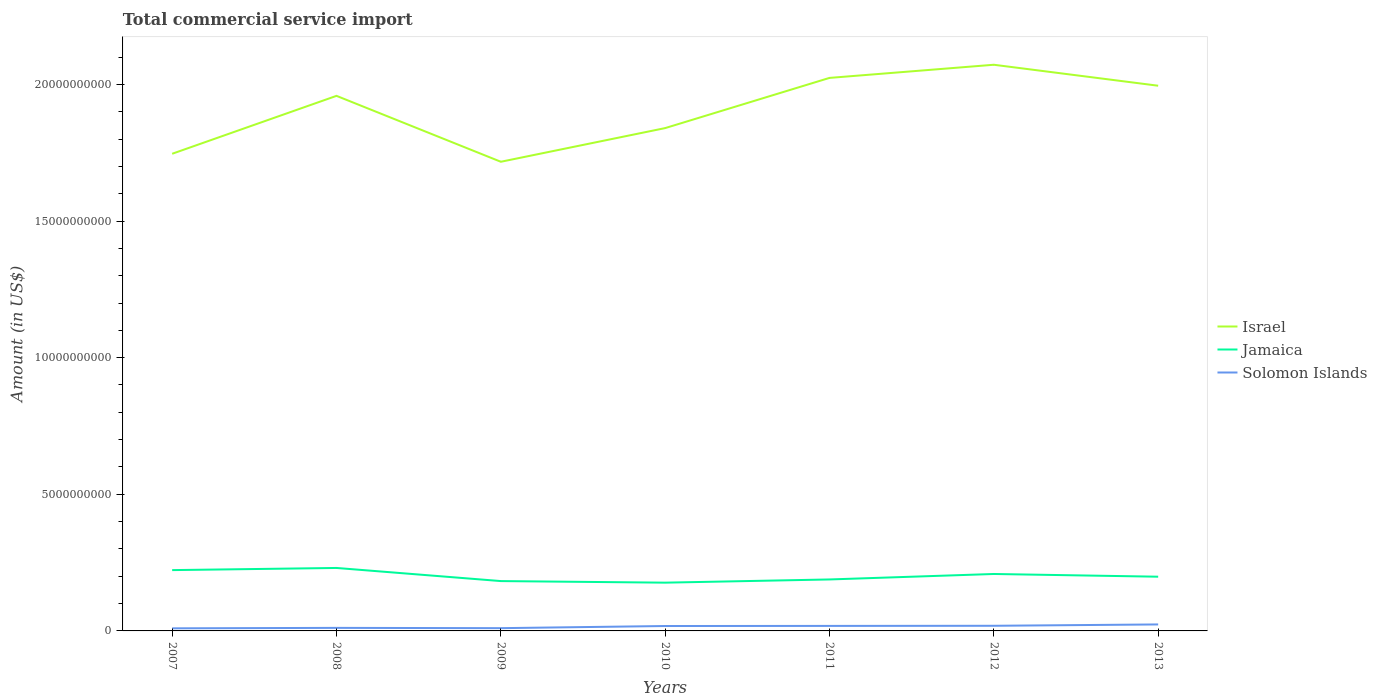Is the number of lines equal to the number of legend labels?
Offer a terse response. Yes. Across all years, what is the maximum total commercial service import in Jamaica?
Your response must be concise. 1.77e+09. In which year was the total commercial service import in Jamaica maximum?
Give a very brief answer. 2010. What is the total total commercial service import in Solomon Islands in the graph?
Provide a short and direct response. -7.22e+07. What is the difference between the highest and the second highest total commercial service import in Solomon Islands?
Ensure brevity in your answer.  1.42e+08. What is the difference between the highest and the lowest total commercial service import in Solomon Islands?
Give a very brief answer. 4. How many lines are there?
Keep it short and to the point. 3. How many years are there in the graph?
Give a very brief answer. 7. Are the values on the major ticks of Y-axis written in scientific E-notation?
Your answer should be compact. No. Does the graph contain any zero values?
Keep it short and to the point. No. What is the title of the graph?
Your answer should be compact. Total commercial service import. Does "Uganda" appear as one of the legend labels in the graph?
Offer a terse response. No. What is the label or title of the X-axis?
Offer a very short reply. Years. What is the Amount (in US$) in Israel in 2007?
Provide a short and direct response. 1.75e+1. What is the Amount (in US$) in Jamaica in 2007?
Give a very brief answer. 2.23e+09. What is the Amount (in US$) of Solomon Islands in 2007?
Keep it short and to the point. 9.48e+07. What is the Amount (in US$) in Israel in 2008?
Your answer should be compact. 1.96e+1. What is the Amount (in US$) in Jamaica in 2008?
Make the answer very short. 2.30e+09. What is the Amount (in US$) in Solomon Islands in 2008?
Your answer should be compact. 1.11e+08. What is the Amount (in US$) in Israel in 2009?
Your response must be concise. 1.72e+1. What is the Amount (in US$) of Jamaica in 2009?
Give a very brief answer. 1.82e+09. What is the Amount (in US$) of Solomon Islands in 2009?
Provide a short and direct response. 1.01e+08. What is the Amount (in US$) in Israel in 2010?
Ensure brevity in your answer.  1.84e+1. What is the Amount (in US$) in Jamaica in 2010?
Offer a very short reply. 1.77e+09. What is the Amount (in US$) in Solomon Islands in 2010?
Give a very brief answer. 1.80e+08. What is the Amount (in US$) of Israel in 2011?
Ensure brevity in your answer.  2.02e+1. What is the Amount (in US$) of Jamaica in 2011?
Your answer should be very brief. 1.88e+09. What is the Amount (in US$) of Solomon Islands in 2011?
Keep it short and to the point. 1.83e+08. What is the Amount (in US$) in Israel in 2012?
Ensure brevity in your answer.  2.07e+1. What is the Amount (in US$) of Jamaica in 2012?
Keep it short and to the point. 2.08e+09. What is the Amount (in US$) of Solomon Islands in 2012?
Offer a terse response. 1.88e+08. What is the Amount (in US$) in Israel in 2013?
Your answer should be very brief. 2.00e+1. What is the Amount (in US$) of Jamaica in 2013?
Give a very brief answer. 1.98e+09. What is the Amount (in US$) of Solomon Islands in 2013?
Your answer should be compact. 2.37e+08. Across all years, what is the maximum Amount (in US$) in Israel?
Your answer should be very brief. 2.07e+1. Across all years, what is the maximum Amount (in US$) in Jamaica?
Offer a very short reply. 2.30e+09. Across all years, what is the maximum Amount (in US$) of Solomon Islands?
Provide a short and direct response. 2.37e+08. Across all years, what is the minimum Amount (in US$) of Israel?
Your response must be concise. 1.72e+1. Across all years, what is the minimum Amount (in US$) in Jamaica?
Your answer should be very brief. 1.77e+09. Across all years, what is the minimum Amount (in US$) in Solomon Islands?
Make the answer very short. 9.48e+07. What is the total Amount (in US$) in Israel in the graph?
Your response must be concise. 1.34e+11. What is the total Amount (in US$) in Jamaica in the graph?
Your answer should be very brief. 1.41e+1. What is the total Amount (in US$) of Solomon Islands in the graph?
Keep it short and to the point. 1.10e+09. What is the difference between the Amount (in US$) in Israel in 2007 and that in 2008?
Your response must be concise. -2.12e+09. What is the difference between the Amount (in US$) in Jamaica in 2007 and that in 2008?
Give a very brief answer. -7.87e+07. What is the difference between the Amount (in US$) in Solomon Islands in 2007 and that in 2008?
Offer a very short reply. -1.65e+07. What is the difference between the Amount (in US$) in Israel in 2007 and that in 2009?
Ensure brevity in your answer.  2.92e+08. What is the difference between the Amount (in US$) of Jamaica in 2007 and that in 2009?
Provide a succinct answer. 4.02e+08. What is the difference between the Amount (in US$) in Solomon Islands in 2007 and that in 2009?
Make the answer very short. -6.20e+06. What is the difference between the Amount (in US$) in Israel in 2007 and that in 2010?
Give a very brief answer. -9.40e+08. What is the difference between the Amount (in US$) of Jamaica in 2007 and that in 2010?
Provide a short and direct response. 4.59e+08. What is the difference between the Amount (in US$) in Solomon Islands in 2007 and that in 2010?
Ensure brevity in your answer.  -8.48e+07. What is the difference between the Amount (in US$) in Israel in 2007 and that in 2011?
Offer a terse response. -2.78e+09. What is the difference between the Amount (in US$) of Jamaica in 2007 and that in 2011?
Keep it short and to the point. 3.42e+08. What is the difference between the Amount (in US$) of Solomon Islands in 2007 and that in 2011?
Your answer should be compact. -8.87e+07. What is the difference between the Amount (in US$) of Israel in 2007 and that in 2012?
Give a very brief answer. -3.26e+09. What is the difference between the Amount (in US$) of Jamaica in 2007 and that in 2012?
Keep it short and to the point. 1.42e+08. What is the difference between the Amount (in US$) of Solomon Islands in 2007 and that in 2012?
Provide a short and direct response. -9.35e+07. What is the difference between the Amount (in US$) of Israel in 2007 and that in 2013?
Keep it short and to the point. -2.49e+09. What is the difference between the Amount (in US$) of Jamaica in 2007 and that in 2013?
Provide a succinct answer. 2.41e+08. What is the difference between the Amount (in US$) in Solomon Islands in 2007 and that in 2013?
Make the answer very short. -1.42e+08. What is the difference between the Amount (in US$) of Israel in 2008 and that in 2009?
Offer a very short reply. 2.41e+09. What is the difference between the Amount (in US$) in Jamaica in 2008 and that in 2009?
Ensure brevity in your answer.  4.80e+08. What is the difference between the Amount (in US$) of Solomon Islands in 2008 and that in 2009?
Your answer should be compact. 1.03e+07. What is the difference between the Amount (in US$) in Israel in 2008 and that in 2010?
Offer a very short reply. 1.18e+09. What is the difference between the Amount (in US$) in Jamaica in 2008 and that in 2010?
Offer a very short reply. 5.38e+08. What is the difference between the Amount (in US$) of Solomon Islands in 2008 and that in 2010?
Give a very brief answer. -6.83e+07. What is the difference between the Amount (in US$) in Israel in 2008 and that in 2011?
Your answer should be very brief. -6.57e+08. What is the difference between the Amount (in US$) in Jamaica in 2008 and that in 2011?
Provide a short and direct response. 4.21e+08. What is the difference between the Amount (in US$) of Solomon Islands in 2008 and that in 2011?
Your response must be concise. -7.22e+07. What is the difference between the Amount (in US$) of Israel in 2008 and that in 2012?
Ensure brevity in your answer.  -1.14e+09. What is the difference between the Amount (in US$) of Jamaica in 2008 and that in 2012?
Provide a succinct answer. 2.20e+08. What is the difference between the Amount (in US$) of Solomon Islands in 2008 and that in 2012?
Ensure brevity in your answer.  -7.70e+07. What is the difference between the Amount (in US$) of Israel in 2008 and that in 2013?
Provide a succinct answer. -3.71e+08. What is the difference between the Amount (in US$) of Jamaica in 2008 and that in 2013?
Your answer should be compact. 3.20e+08. What is the difference between the Amount (in US$) in Solomon Islands in 2008 and that in 2013?
Offer a terse response. -1.26e+08. What is the difference between the Amount (in US$) in Israel in 2009 and that in 2010?
Keep it short and to the point. -1.23e+09. What is the difference between the Amount (in US$) in Jamaica in 2009 and that in 2010?
Your answer should be very brief. 5.75e+07. What is the difference between the Amount (in US$) in Solomon Islands in 2009 and that in 2010?
Make the answer very short. -7.86e+07. What is the difference between the Amount (in US$) of Israel in 2009 and that in 2011?
Provide a succinct answer. -3.07e+09. What is the difference between the Amount (in US$) in Jamaica in 2009 and that in 2011?
Provide a succinct answer. -5.96e+07. What is the difference between the Amount (in US$) in Solomon Islands in 2009 and that in 2011?
Offer a very short reply. -8.25e+07. What is the difference between the Amount (in US$) of Israel in 2009 and that in 2012?
Make the answer very short. -3.55e+09. What is the difference between the Amount (in US$) of Jamaica in 2009 and that in 2012?
Keep it short and to the point. -2.60e+08. What is the difference between the Amount (in US$) of Solomon Islands in 2009 and that in 2012?
Your answer should be compact. -8.73e+07. What is the difference between the Amount (in US$) of Israel in 2009 and that in 2013?
Keep it short and to the point. -2.78e+09. What is the difference between the Amount (in US$) of Jamaica in 2009 and that in 2013?
Keep it short and to the point. -1.60e+08. What is the difference between the Amount (in US$) of Solomon Islands in 2009 and that in 2013?
Your answer should be compact. -1.36e+08. What is the difference between the Amount (in US$) of Israel in 2010 and that in 2011?
Offer a very short reply. -1.84e+09. What is the difference between the Amount (in US$) in Jamaica in 2010 and that in 2011?
Give a very brief answer. -1.17e+08. What is the difference between the Amount (in US$) of Solomon Islands in 2010 and that in 2011?
Your answer should be very brief. -3.90e+06. What is the difference between the Amount (in US$) of Israel in 2010 and that in 2012?
Your answer should be compact. -2.32e+09. What is the difference between the Amount (in US$) in Jamaica in 2010 and that in 2012?
Offer a very short reply. -3.17e+08. What is the difference between the Amount (in US$) in Solomon Islands in 2010 and that in 2012?
Keep it short and to the point. -8.73e+06. What is the difference between the Amount (in US$) in Israel in 2010 and that in 2013?
Provide a succinct answer. -1.55e+09. What is the difference between the Amount (in US$) in Jamaica in 2010 and that in 2013?
Make the answer very short. -2.18e+08. What is the difference between the Amount (in US$) of Solomon Islands in 2010 and that in 2013?
Offer a terse response. -5.77e+07. What is the difference between the Amount (in US$) in Israel in 2011 and that in 2012?
Provide a succinct answer. -4.81e+08. What is the difference between the Amount (in US$) in Jamaica in 2011 and that in 2012?
Your response must be concise. -2.00e+08. What is the difference between the Amount (in US$) in Solomon Islands in 2011 and that in 2012?
Your response must be concise. -4.83e+06. What is the difference between the Amount (in US$) of Israel in 2011 and that in 2013?
Ensure brevity in your answer.  2.86e+08. What is the difference between the Amount (in US$) in Jamaica in 2011 and that in 2013?
Offer a terse response. -1.01e+08. What is the difference between the Amount (in US$) in Solomon Islands in 2011 and that in 2013?
Keep it short and to the point. -5.38e+07. What is the difference between the Amount (in US$) of Israel in 2012 and that in 2013?
Offer a very short reply. 7.67e+08. What is the difference between the Amount (in US$) of Jamaica in 2012 and that in 2013?
Provide a short and direct response. 9.95e+07. What is the difference between the Amount (in US$) of Solomon Islands in 2012 and that in 2013?
Your response must be concise. -4.90e+07. What is the difference between the Amount (in US$) in Israel in 2007 and the Amount (in US$) in Jamaica in 2008?
Your answer should be very brief. 1.52e+1. What is the difference between the Amount (in US$) of Israel in 2007 and the Amount (in US$) of Solomon Islands in 2008?
Make the answer very short. 1.74e+1. What is the difference between the Amount (in US$) in Jamaica in 2007 and the Amount (in US$) in Solomon Islands in 2008?
Make the answer very short. 2.11e+09. What is the difference between the Amount (in US$) of Israel in 2007 and the Amount (in US$) of Jamaica in 2009?
Give a very brief answer. 1.56e+1. What is the difference between the Amount (in US$) in Israel in 2007 and the Amount (in US$) in Solomon Islands in 2009?
Ensure brevity in your answer.  1.74e+1. What is the difference between the Amount (in US$) of Jamaica in 2007 and the Amount (in US$) of Solomon Islands in 2009?
Provide a succinct answer. 2.12e+09. What is the difference between the Amount (in US$) in Israel in 2007 and the Amount (in US$) in Jamaica in 2010?
Provide a short and direct response. 1.57e+1. What is the difference between the Amount (in US$) of Israel in 2007 and the Amount (in US$) of Solomon Islands in 2010?
Keep it short and to the point. 1.73e+1. What is the difference between the Amount (in US$) in Jamaica in 2007 and the Amount (in US$) in Solomon Islands in 2010?
Provide a succinct answer. 2.05e+09. What is the difference between the Amount (in US$) of Israel in 2007 and the Amount (in US$) of Jamaica in 2011?
Offer a terse response. 1.56e+1. What is the difference between the Amount (in US$) in Israel in 2007 and the Amount (in US$) in Solomon Islands in 2011?
Make the answer very short. 1.73e+1. What is the difference between the Amount (in US$) of Jamaica in 2007 and the Amount (in US$) of Solomon Islands in 2011?
Offer a very short reply. 2.04e+09. What is the difference between the Amount (in US$) of Israel in 2007 and the Amount (in US$) of Jamaica in 2012?
Provide a short and direct response. 1.54e+1. What is the difference between the Amount (in US$) of Israel in 2007 and the Amount (in US$) of Solomon Islands in 2012?
Ensure brevity in your answer.  1.73e+1. What is the difference between the Amount (in US$) of Jamaica in 2007 and the Amount (in US$) of Solomon Islands in 2012?
Give a very brief answer. 2.04e+09. What is the difference between the Amount (in US$) in Israel in 2007 and the Amount (in US$) in Jamaica in 2013?
Make the answer very short. 1.55e+1. What is the difference between the Amount (in US$) in Israel in 2007 and the Amount (in US$) in Solomon Islands in 2013?
Ensure brevity in your answer.  1.72e+1. What is the difference between the Amount (in US$) of Jamaica in 2007 and the Amount (in US$) of Solomon Islands in 2013?
Offer a terse response. 1.99e+09. What is the difference between the Amount (in US$) of Israel in 2008 and the Amount (in US$) of Jamaica in 2009?
Keep it short and to the point. 1.78e+1. What is the difference between the Amount (in US$) of Israel in 2008 and the Amount (in US$) of Solomon Islands in 2009?
Your answer should be very brief. 1.95e+1. What is the difference between the Amount (in US$) of Jamaica in 2008 and the Amount (in US$) of Solomon Islands in 2009?
Your answer should be very brief. 2.20e+09. What is the difference between the Amount (in US$) in Israel in 2008 and the Amount (in US$) in Jamaica in 2010?
Your answer should be very brief. 1.78e+1. What is the difference between the Amount (in US$) of Israel in 2008 and the Amount (in US$) of Solomon Islands in 2010?
Your response must be concise. 1.94e+1. What is the difference between the Amount (in US$) of Jamaica in 2008 and the Amount (in US$) of Solomon Islands in 2010?
Provide a succinct answer. 2.12e+09. What is the difference between the Amount (in US$) of Israel in 2008 and the Amount (in US$) of Jamaica in 2011?
Keep it short and to the point. 1.77e+1. What is the difference between the Amount (in US$) in Israel in 2008 and the Amount (in US$) in Solomon Islands in 2011?
Give a very brief answer. 1.94e+1. What is the difference between the Amount (in US$) in Jamaica in 2008 and the Amount (in US$) in Solomon Islands in 2011?
Keep it short and to the point. 2.12e+09. What is the difference between the Amount (in US$) of Israel in 2008 and the Amount (in US$) of Jamaica in 2012?
Offer a very short reply. 1.75e+1. What is the difference between the Amount (in US$) of Israel in 2008 and the Amount (in US$) of Solomon Islands in 2012?
Make the answer very short. 1.94e+1. What is the difference between the Amount (in US$) in Jamaica in 2008 and the Amount (in US$) in Solomon Islands in 2012?
Offer a very short reply. 2.12e+09. What is the difference between the Amount (in US$) in Israel in 2008 and the Amount (in US$) in Jamaica in 2013?
Your answer should be compact. 1.76e+1. What is the difference between the Amount (in US$) in Israel in 2008 and the Amount (in US$) in Solomon Islands in 2013?
Provide a succinct answer. 1.93e+1. What is the difference between the Amount (in US$) of Jamaica in 2008 and the Amount (in US$) of Solomon Islands in 2013?
Provide a short and direct response. 2.07e+09. What is the difference between the Amount (in US$) in Israel in 2009 and the Amount (in US$) in Jamaica in 2010?
Offer a very short reply. 1.54e+1. What is the difference between the Amount (in US$) of Israel in 2009 and the Amount (in US$) of Solomon Islands in 2010?
Offer a very short reply. 1.70e+1. What is the difference between the Amount (in US$) of Jamaica in 2009 and the Amount (in US$) of Solomon Islands in 2010?
Offer a terse response. 1.64e+09. What is the difference between the Amount (in US$) of Israel in 2009 and the Amount (in US$) of Jamaica in 2011?
Provide a short and direct response. 1.53e+1. What is the difference between the Amount (in US$) of Israel in 2009 and the Amount (in US$) of Solomon Islands in 2011?
Make the answer very short. 1.70e+1. What is the difference between the Amount (in US$) in Jamaica in 2009 and the Amount (in US$) in Solomon Islands in 2011?
Offer a terse response. 1.64e+09. What is the difference between the Amount (in US$) in Israel in 2009 and the Amount (in US$) in Jamaica in 2012?
Give a very brief answer. 1.51e+1. What is the difference between the Amount (in US$) in Israel in 2009 and the Amount (in US$) in Solomon Islands in 2012?
Keep it short and to the point. 1.70e+1. What is the difference between the Amount (in US$) in Jamaica in 2009 and the Amount (in US$) in Solomon Islands in 2012?
Provide a short and direct response. 1.64e+09. What is the difference between the Amount (in US$) in Israel in 2009 and the Amount (in US$) in Jamaica in 2013?
Your answer should be compact. 1.52e+1. What is the difference between the Amount (in US$) in Israel in 2009 and the Amount (in US$) in Solomon Islands in 2013?
Make the answer very short. 1.69e+1. What is the difference between the Amount (in US$) in Jamaica in 2009 and the Amount (in US$) in Solomon Islands in 2013?
Your answer should be very brief. 1.59e+09. What is the difference between the Amount (in US$) in Israel in 2010 and the Amount (in US$) in Jamaica in 2011?
Give a very brief answer. 1.65e+1. What is the difference between the Amount (in US$) of Israel in 2010 and the Amount (in US$) of Solomon Islands in 2011?
Your answer should be very brief. 1.82e+1. What is the difference between the Amount (in US$) in Jamaica in 2010 and the Amount (in US$) in Solomon Islands in 2011?
Provide a succinct answer. 1.58e+09. What is the difference between the Amount (in US$) in Israel in 2010 and the Amount (in US$) in Jamaica in 2012?
Make the answer very short. 1.63e+1. What is the difference between the Amount (in US$) of Israel in 2010 and the Amount (in US$) of Solomon Islands in 2012?
Provide a short and direct response. 1.82e+1. What is the difference between the Amount (in US$) in Jamaica in 2010 and the Amount (in US$) in Solomon Islands in 2012?
Your answer should be compact. 1.58e+09. What is the difference between the Amount (in US$) of Israel in 2010 and the Amount (in US$) of Jamaica in 2013?
Your answer should be compact. 1.64e+1. What is the difference between the Amount (in US$) of Israel in 2010 and the Amount (in US$) of Solomon Islands in 2013?
Provide a succinct answer. 1.82e+1. What is the difference between the Amount (in US$) of Jamaica in 2010 and the Amount (in US$) of Solomon Islands in 2013?
Make the answer very short. 1.53e+09. What is the difference between the Amount (in US$) in Israel in 2011 and the Amount (in US$) in Jamaica in 2012?
Offer a very short reply. 1.82e+1. What is the difference between the Amount (in US$) in Israel in 2011 and the Amount (in US$) in Solomon Islands in 2012?
Provide a succinct answer. 2.01e+1. What is the difference between the Amount (in US$) of Jamaica in 2011 and the Amount (in US$) of Solomon Islands in 2012?
Provide a short and direct response. 1.70e+09. What is the difference between the Amount (in US$) in Israel in 2011 and the Amount (in US$) in Jamaica in 2013?
Your response must be concise. 1.83e+1. What is the difference between the Amount (in US$) in Israel in 2011 and the Amount (in US$) in Solomon Islands in 2013?
Make the answer very short. 2.00e+1. What is the difference between the Amount (in US$) of Jamaica in 2011 and the Amount (in US$) of Solomon Islands in 2013?
Make the answer very short. 1.65e+09. What is the difference between the Amount (in US$) of Israel in 2012 and the Amount (in US$) of Jamaica in 2013?
Provide a succinct answer. 1.87e+1. What is the difference between the Amount (in US$) in Israel in 2012 and the Amount (in US$) in Solomon Islands in 2013?
Your answer should be very brief. 2.05e+1. What is the difference between the Amount (in US$) of Jamaica in 2012 and the Amount (in US$) of Solomon Islands in 2013?
Your answer should be compact. 1.85e+09. What is the average Amount (in US$) in Israel per year?
Provide a succinct answer. 1.91e+1. What is the average Amount (in US$) in Jamaica per year?
Give a very brief answer. 2.01e+09. What is the average Amount (in US$) in Solomon Islands per year?
Offer a terse response. 1.56e+08. In the year 2007, what is the difference between the Amount (in US$) of Israel and Amount (in US$) of Jamaica?
Ensure brevity in your answer.  1.52e+1. In the year 2007, what is the difference between the Amount (in US$) of Israel and Amount (in US$) of Solomon Islands?
Give a very brief answer. 1.74e+1. In the year 2007, what is the difference between the Amount (in US$) of Jamaica and Amount (in US$) of Solomon Islands?
Ensure brevity in your answer.  2.13e+09. In the year 2008, what is the difference between the Amount (in US$) of Israel and Amount (in US$) of Jamaica?
Keep it short and to the point. 1.73e+1. In the year 2008, what is the difference between the Amount (in US$) in Israel and Amount (in US$) in Solomon Islands?
Provide a short and direct response. 1.95e+1. In the year 2008, what is the difference between the Amount (in US$) of Jamaica and Amount (in US$) of Solomon Islands?
Your answer should be compact. 2.19e+09. In the year 2009, what is the difference between the Amount (in US$) in Israel and Amount (in US$) in Jamaica?
Offer a very short reply. 1.53e+1. In the year 2009, what is the difference between the Amount (in US$) of Israel and Amount (in US$) of Solomon Islands?
Offer a very short reply. 1.71e+1. In the year 2009, what is the difference between the Amount (in US$) of Jamaica and Amount (in US$) of Solomon Islands?
Your answer should be very brief. 1.72e+09. In the year 2010, what is the difference between the Amount (in US$) in Israel and Amount (in US$) in Jamaica?
Your response must be concise. 1.66e+1. In the year 2010, what is the difference between the Amount (in US$) of Israel and Amount (in US$) of Solomon Islands?
Offer a terse response. 1.82e+1. In the year 2010, what is the difference between the Amount (in US$) in Jamaica and Amount (in US$) in Solomon Islands?
Your answer should be very brief. 1.59e+09. In the year 2011, what is the difference between the Amount (in US$) of Israel and Amount (in US$) of Jamaica?
Make the answer very short. 1.84e+1. In the year 2011, what is the difference between the Amount (in US$) in Israel and Amount (in US$) in Solomon Islands?
Your answer should be very brief. 2.01e+1. In the year 2011, what is the difference between the Amount (in US$) of Jamaica and Amount (in US$) of Solomon Islands?
Make the answer very short. 1.70e+09. In the year 2012, what is the difference between the Amount (in US$) in Israel and Amount (in US$) in Jamaica?
Ensure brevity in your answer.  1.86e+1. In the year 2012, what is the difference between the Amount (in US$) of Israel and Amount (in US$) of Solomon Islands?
Your answer should be very brief. 2.05e+1. In the year 2012, what is the difference between the Amount (in US$) of Jamaica and Amount (in US$) of Solomon Islands?
Ensure brevity in your answer.  1.90e+09. In the year 2013, what is the difference between the Amount (in US$) of Israel and Amount (in US$) of Jamaica?
Offer a very short reply. 1.80e+1. In the year 2013, what is the difference between the Amount (in US$) of Israel and Amount (in US$) of Solomon Islands?
Provide a short and direct response. 1.97e+1. In the year 2013, what is the difference between the Amount (in US$) in Jamaica and Amount (in US$) in Solomon Islands?
Your answer should be compact. 1.75e+09. What is the ratio of the Amount (in US$) in Israel in 2007 to that in 2008?
Provide a short and direct response. 0.89. What is the ratio of the Amount (in US$) of Jamaica in 2007 to that in 2008?
Provide a succinct answer. 0.97. What is the ratio of the Amount (in US$) of Solomon Islands in 2007 to that in 2008?
Ensure brevity in your answer.  0.85. What is the ratio of the Amount (in US$) of Israel in 2007 to that in 2009?
Offer a terse response. 1.02. What is the ratio of the Amount (in US$) in Jamaica in 2007 to that in 2009?
Make the answer very short. 1.22. What is the ratio of the Amount (in US$) in Solomon Islands in 2007 to that in 2009?
Keep it short and to the point. 0.94. What is the ratio of the Amount (in US$) in Israel in 2007 to that in 2010?
Give a very brief answer. 0.95. What is the ratio of the Amount (in US$) in Jamaica in 2007 to that in 2010?
Provide a short and direct response. 1.26. What is the ratio of the Amount (in US$) in Solomon Islands in 2007 to that in 2010?
Offer a very short reply. 0.53. What is the ratio of the Amount (in US$) in Israel in 2007 to that in 2011?
Your answer should be compact. 0.86. What is the ratio of the Amount (in US$) of Jamaica in 2007 to that in 2011?
Offer a very short reply. 1.18. What is the ratio of the Amount (in US$) in Solomon Islands in 2007 to that in 2011?
Give a very brief answer. 0.52. What is the ratio of the Amount (in US$) of Israel in 2007 to that in 2012?
Provide a short and direct response. 0.84. What is the ratio of the Amount (in US$) of Jamaica in 2007 to that in 2012?
Ensure brevity in your answer.  1.07. What is the ratio of the Amount (in US$) of Solomon Islands in 2007 to that in 2012?
Your response must be concise. 0.5. What is the ratio of the Amount (in US$) of Israel in 2007 to that in 2013?
Give a very brief answer. 0.88. What is the ratio of the Amount (in US$) of Jamaica in 2007 to that in 2013?
Ensure brevity in your answer.  1.12. What is the ratio of the Amount (in US$) of Solomon Islands in 2007 to that in 2013?
Give a very brief answer. 0.4. What is the ratio of the Amount (in US$) in Israel in 2008 to that in 2009?
Make the answer very short. 1.14. What is the ratio of the Amount (in US$) in Jamaica in 2008 to that in 2009?
Make the answer very short. 1.26. What is the ratio of the Amount (in US$) of Solomon Islands in 2008 to that in 2009?
Make the answer very short. 1.1. What is the ratio of the Amount (in US$) in Israel in 2008 to that in 2010?
Offer a very short reply. 1.06. What is the ratio of the Amount (in US$) in Jamaica in 2008 to that in 2010?
Your response must be concise. 1.3. What is the ratio of the Amount (in US$) in Solomon Islands in 2008 to that in 2010?
Offer a terse response. 0.62. What is the ratio of the Amount (in US$) in Israel in 2008 to that in 2011?
Offer a very short reply. 0.97. What is the ratio of the Amount (in US$) in Jamaica in 2008 to that in 2011?
Provide a short and direct response. 1.22. What is the ratio of the Amount (in US$) of Solomon Islands in 2008 to that in 2011?
Your response must be concise. 0.61. What is the ratio of the Amount (in US$) in Israel in 2008 to that in 2012?
Offer a terse response. 0.95. What is the ratio of the Amount (in US$) in Jamaica in 2008 to that in 2012?
Offer a terse response. 1.11. What is the ratio of the Amount (in US$) of Solomon Islands in 2008 to that in 2012?
Provide a short and direct response. 0.59. What is the ratio of the Amount (in US$) in Israel in 2008 to that in 2013?
Offer a terse response. 0.98. What is the ratio of the Amount (in US$) of Jamaica in 2008 to that in 2013?
Offer a terse response. 1.16. What is the ratio of the Amount (in US$) of Solomon Islands in 2008 to that in 2013?
Make the answer very short. 0.47. What is the ratio of the Amount (in US$) in Israel in 2009 to that in 2010?
Your response must be concise. 0.93. What is the ratio of the Amount (in US$) in Jamaica in 2009 to that in 2010?
Give a very brief answer. 1.03. What is the ratio of the Amount (in US$) in Solomon Islands in 2009 to that in 2010?
Offer a very short reply. 0.56. What is the ratio of the Amount (in US$) in Israel in 2009 to that in 2011?
Give a very brief answer. 0.85. What is the ratio of the Amount (in US$) of Jamaica in 2009 to that in 2011?
Offer a very short reply. 0.97. What is the ratio of the Amount (in US$) in Solomon Islands in 2009 to that in 2011?
Ensure brevity in your answer.  0.55. What is the ratio of the Amount (in US$) in Israel in 2009 to that in 2012?
Your response must be concise. 0.83. What is the ratio of the Amount (in US$) of Jamaica in 2009 to that in 2012?
Your answer should be very brief. 0.88. What is the ratio of the Amount (in US$) in Solomon Islands in 2009 to that in 2012?
Provide a succinct answer. 0.54. What is the ratio of the Amount (in US$) of Israel in 2009 to that in 2013?
Ensure brevity in your answer.  0.86. What is the ratio of the Amount (in US$) of Jamaica in 2009 to that in 2013?
Make the answer very short. 0.92. What is the ratio of the Amount (in US$) of Solomon Islands in 2009 to that in 2013?
Provide a succinct answer. 0.43. What is the ratio of the Amount (in US$) in Israel in 2010 to that in 2011?
Offer a very short reply. 0.91. What is the ratio of the Amount (in US$) in Jamaica in 2010 to that in 2011?
Provide a short and direct response. 0.94. What is the ratio of the Amount (in US$) in Solomon Islands in 2010 to that in 2011?
Provide a short and direct response. 0.98. What is the ratio of the Amount (in US$) in Israel in 2010 to that in 2012?
Make the answer very short. 0.89. What is the ratio of the Amount (in US$) in Jamaica in 2010 to that in 2012?
Ensure brevity in your answer.  0.85. What is the ratio of the Amount (in US$) in Solomon Islands in 2010 to that in 2012?
Give a very brief answer. 0.95. What is the ratio of the Amount (in US$) of Israel in 2010 to that in 2013?
Make the answer very short. 0.92. What is the ratio of the Amount (in US$) in Jamaica in 2010 to that in 2013?
Make the answer very short. 0.89. What is the ratio of the Amount (in US$) in Solomon Islands in 2010 to that in 2013?
Give a very brief answer. 0.76. What is the ratio of the Amount (in US$) of Israel in 2011 to that in 2012?
Your answer should be compact. 0.98. What is the ratio of the Amount (in US$) in Jamaica in 2011 to that in 2012?
Provide a short and direct response. 0.9. What is the ratio of the Amount (in US$) in Solomon Islands in 2011 to that in 2012?
Your answer should be compact. 0.97. What is the ratio of the Amount (in US$) of Israel in 2011 to that in 2013?
Offer a terse response. 1.01. What is the ratio of the Amount (in US$) of Jamaica in 2011 to that in 2013?
Your answer should be very brief. 0.95. What is the ratio of the Amount (in US$) in Solomon Islands in 2011 to that in 2013?
Provide a succinct answer. 0.77. What is the ratio of the Amount (in US$) in Jamaica in 2012 to that in 2013?
Keep it short and to the point. 1.05. What is the ratio of the Amount (in US$) of Solomon Islands in 2012 to that in 2013?
Provide a short and direct response. 0.79. What is the difference between the highest and the second highest Amount (in US$) of Israel?
Ensure brevity in your answer.  4.81e+08. What is the difference between the highest and the second highest Amount (in US$) in Jamaica?
Offer a terse response. 7.87e+07. What is the difference between the highest and the second highest Amount (in US$) in Solomon Islands?
Provide a short and direct response. 4.90e+07. What is the difference between the highest and the lowest Amount (in US$) in Israel?
Offer a terse response. 3.55e+09. What is the difference between the highest and the lowest Amount (in US$) of Jamaica?
Ensure brevity in your answer.  5.38e+08. What is the difference between the highest and the lowest Amount (in US$) of Solomon Islands?
Keep it short and to the point. 1.42e+08. 